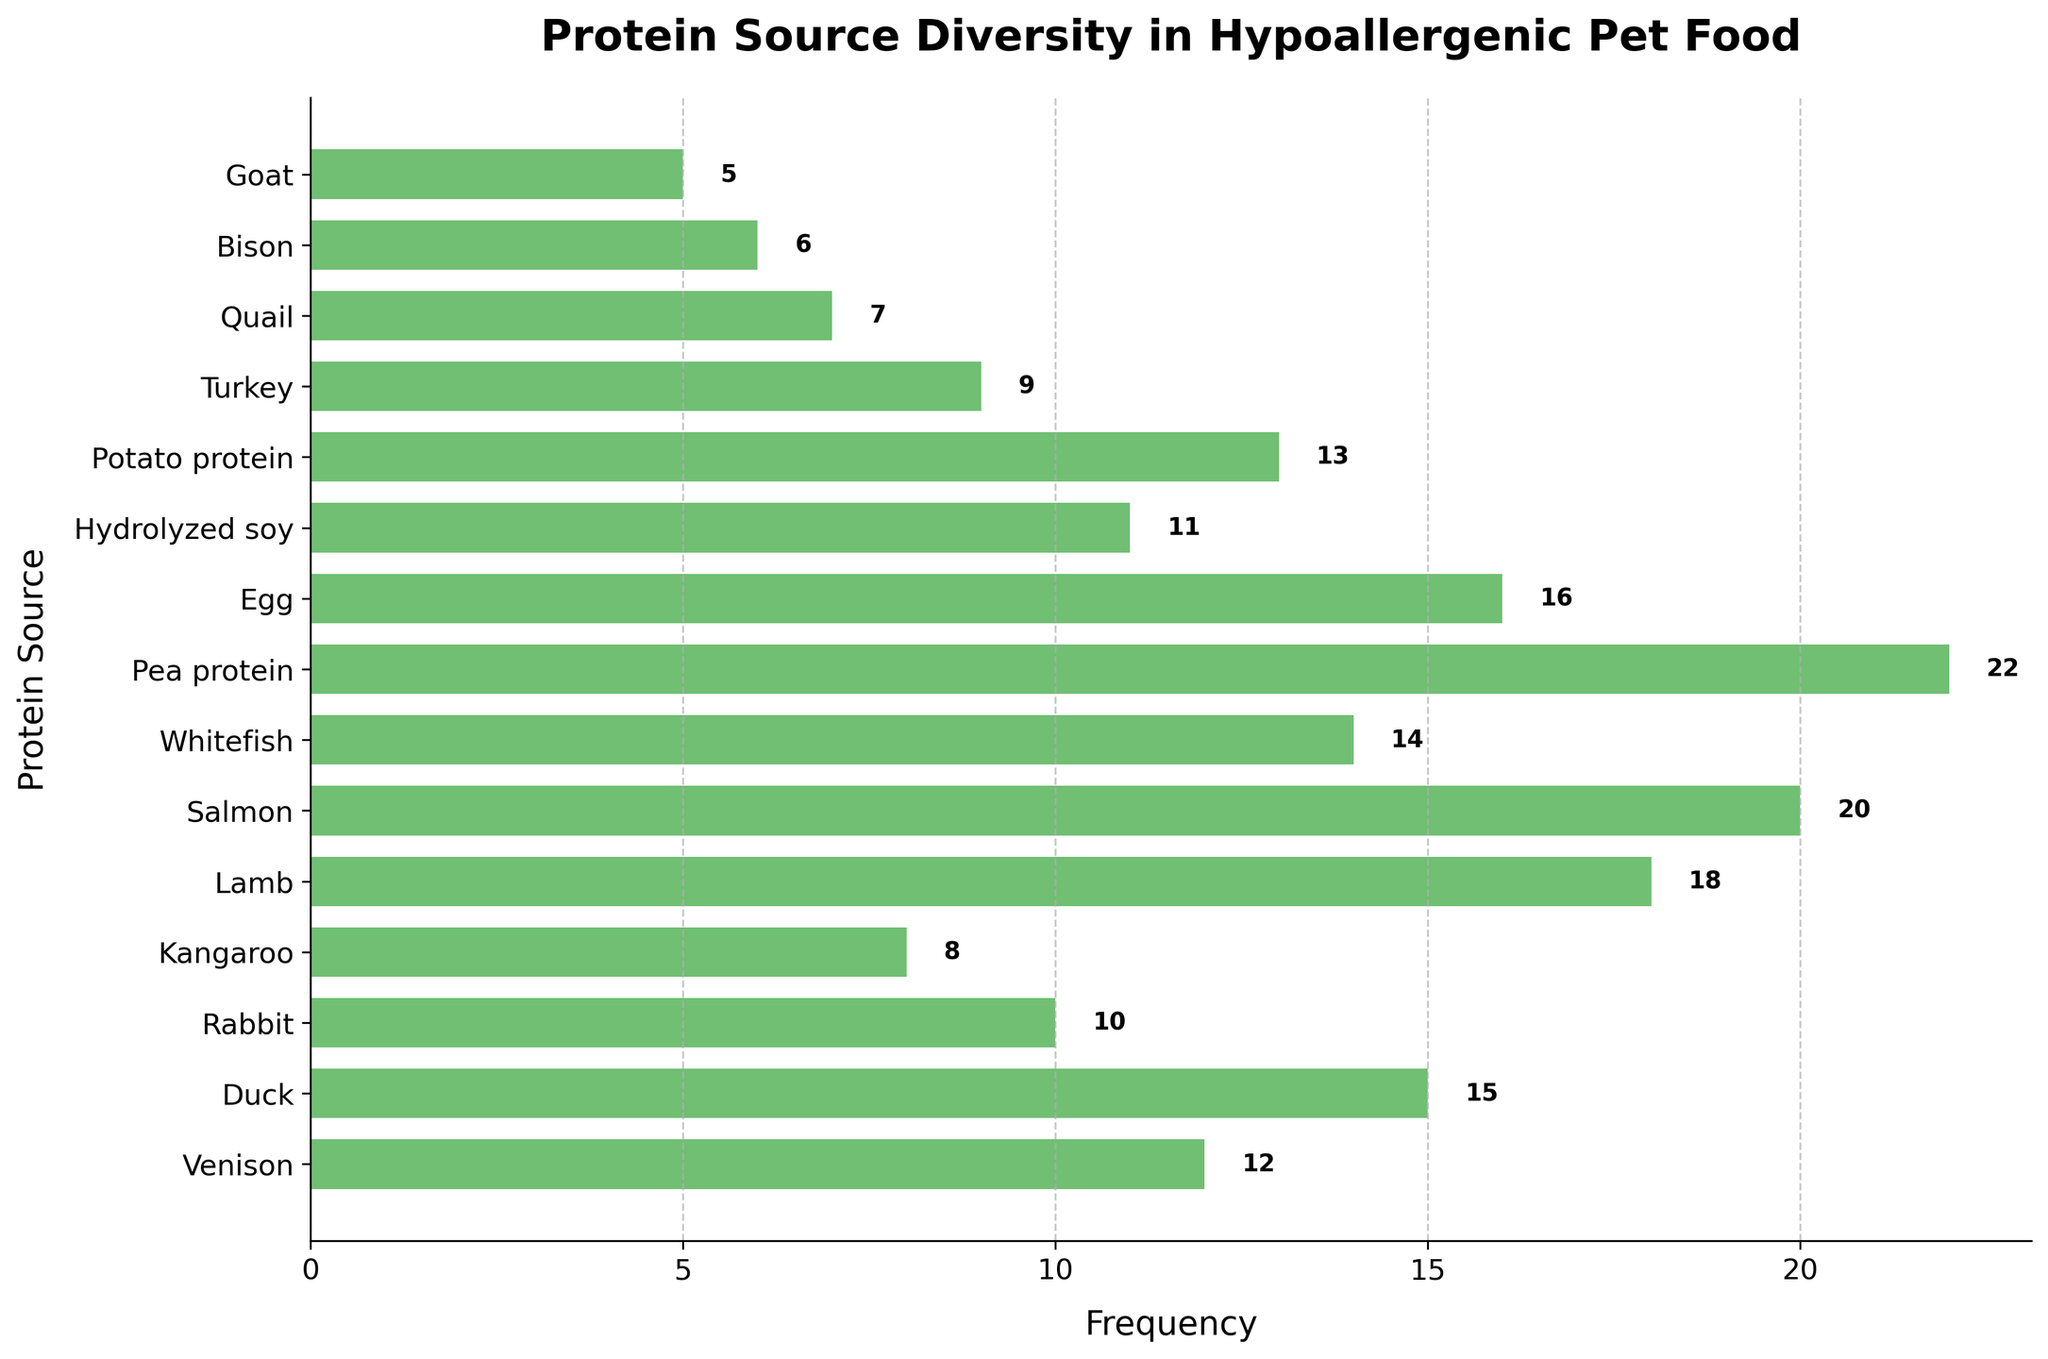What's the title of the plot? The title is prominently displayed at the top of the plot.
Answer: Protein Source Diversity in Hypoallergenic Pet Food Which protein source has the highest frequency? The frequencies are displayed next to each bar, and the longest bar represents the highest frequency.
Answer: Pea protein How many protein sources are represented in this plot? Count the distinct protein sources listed along the y-axis.
Answer: 15 What is the frequency of Duck as a protein source? Look at the bar labeled "Duck" and read the number displayed next to it.
Answer: 15 Which protein source has a frequency of 16? Identify the bar with a frequency value of 16 and read the corresponding protein source label.
Answer: Egg What is the combined frequency of Venison and Rabbit? Add the frequencies of Venison (12) and Rabbit (10). 12 + 10 = 22
Answer: 22 Is the frequency of Turkey greater than or less than the frequency of Whitefish? Compare the length of the bars for Turkey and Whitefish. Turkey has 9, and Whitefish has 14.
Answer: Less than Which protein source has the second lowest frequency? Identify the shortest bars and then determine the second shortest.
Answer: Goat What is the average frequency of the hypoallergenic protein sources? Sum all the frequencies and divide by the number of protein sources. (12 + 15 + 10 + 8 + 18 + 20 + 14 + 22 + 16 + 11 + 13 + 9 + 7 + 6 + 5) / 15 = 186 / 15 = 12.4
Answer: 12.4 Which protein source frequencies are greater than 15 but less than 20? Identify bars with values between 15 and 20.
Answer: Lamb, Salmon, Egg 